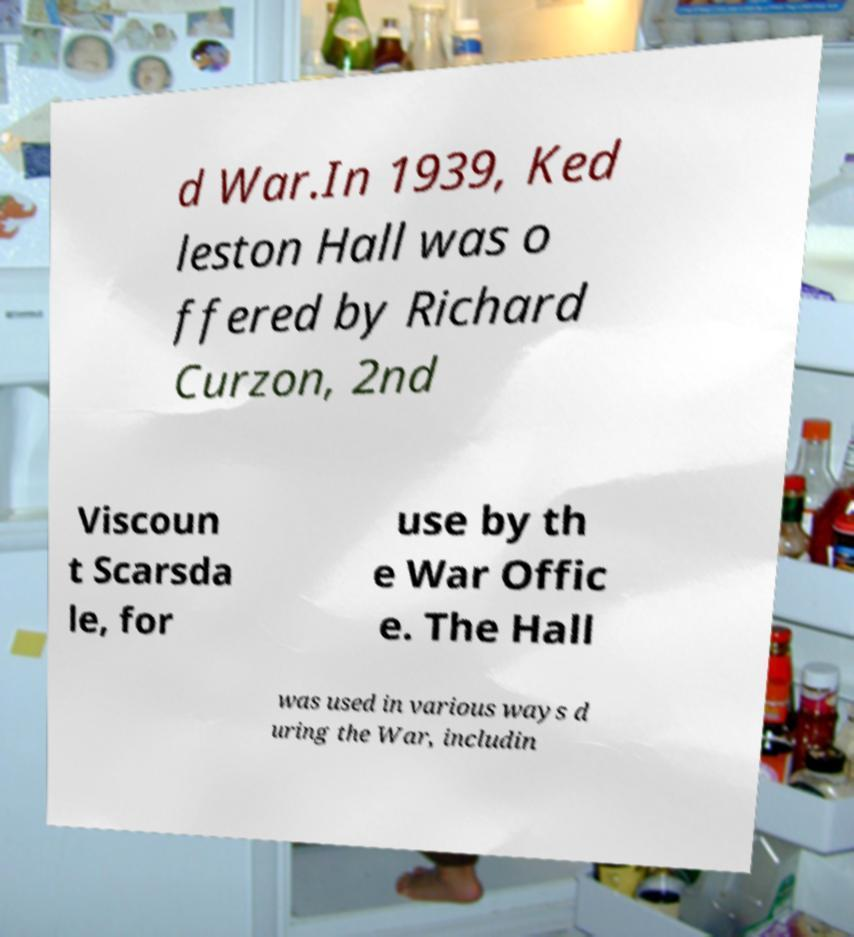Can you read and provide the text displayed in the image?This photo seems to have some interesting text. Can you extract and type it out for me? d War.In 1939, Ked leston Hall was o ffered by Richard Curzon, 2nd Viscoun t Scarsda le, for use by th e War Offic e. The Hall was used in various ways d uring the War, includin 